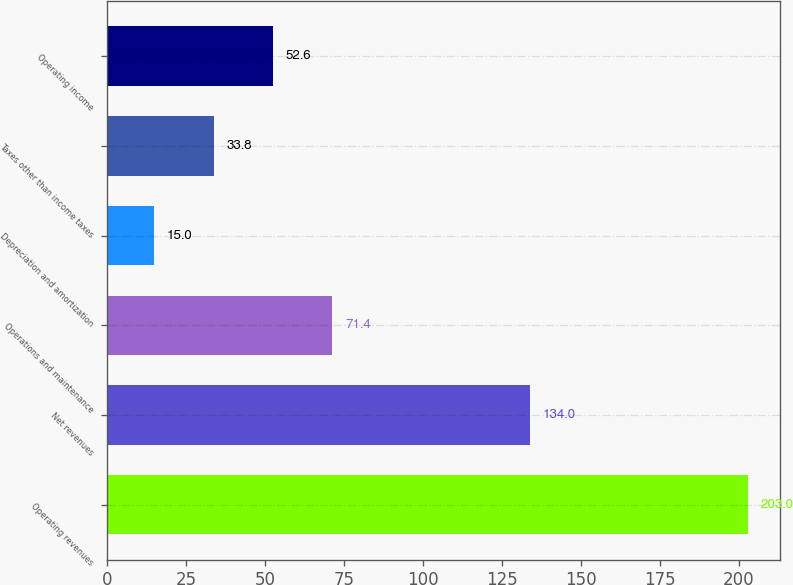Convert chart to OTSL. <chart><loc_0><loc_0><loc_500><loc_500><bar_chart><fcel>Operating revenues<fcel>Net revenues<fcel>Operations and maintenance<fcel>Depreciation and amortization<fcel>Taxes other than income taxes<fcel>Operating income<nl><fcel>203<fcel>134<fcel>71.4<fcel>15<fcel>33.8<fcel>52.6<nl></chart> 